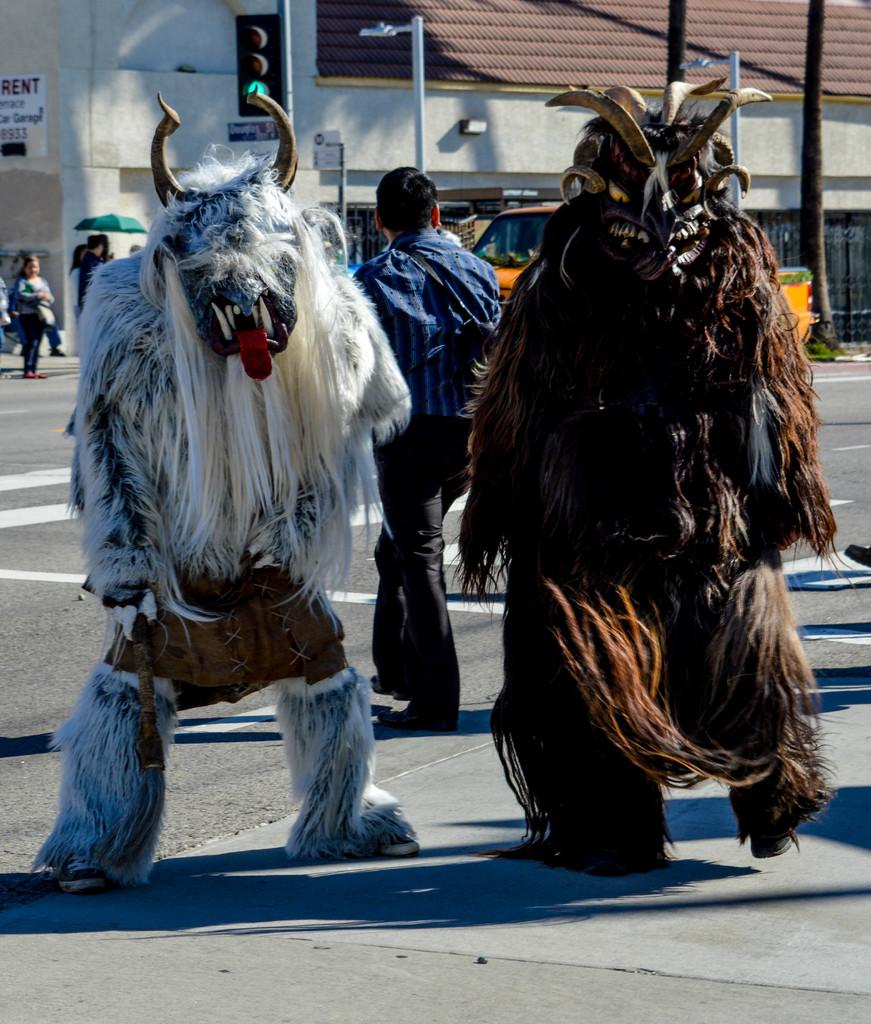What type of cartoons are depicted in the image? There are mask cartoons in the image. Can you describe the people in the image? There are people in the image, but their specific actions or characteristics are not mentioned in the facts. What type of infrastructure can be seen in the image? Electrical poles and traffic lights are visible in the image. What type of building is present in the image? There is a house in the image. What other object can be seen in the image? There is a board in the image. What type of toy is being used to spread jam on the board in the image? There is no toy or jam present in the image; it features mask cartoons, people, electrical poles, traffic lights, a house, and a board. How many matches are visible on the board in the image? There are no matches present in the image. 